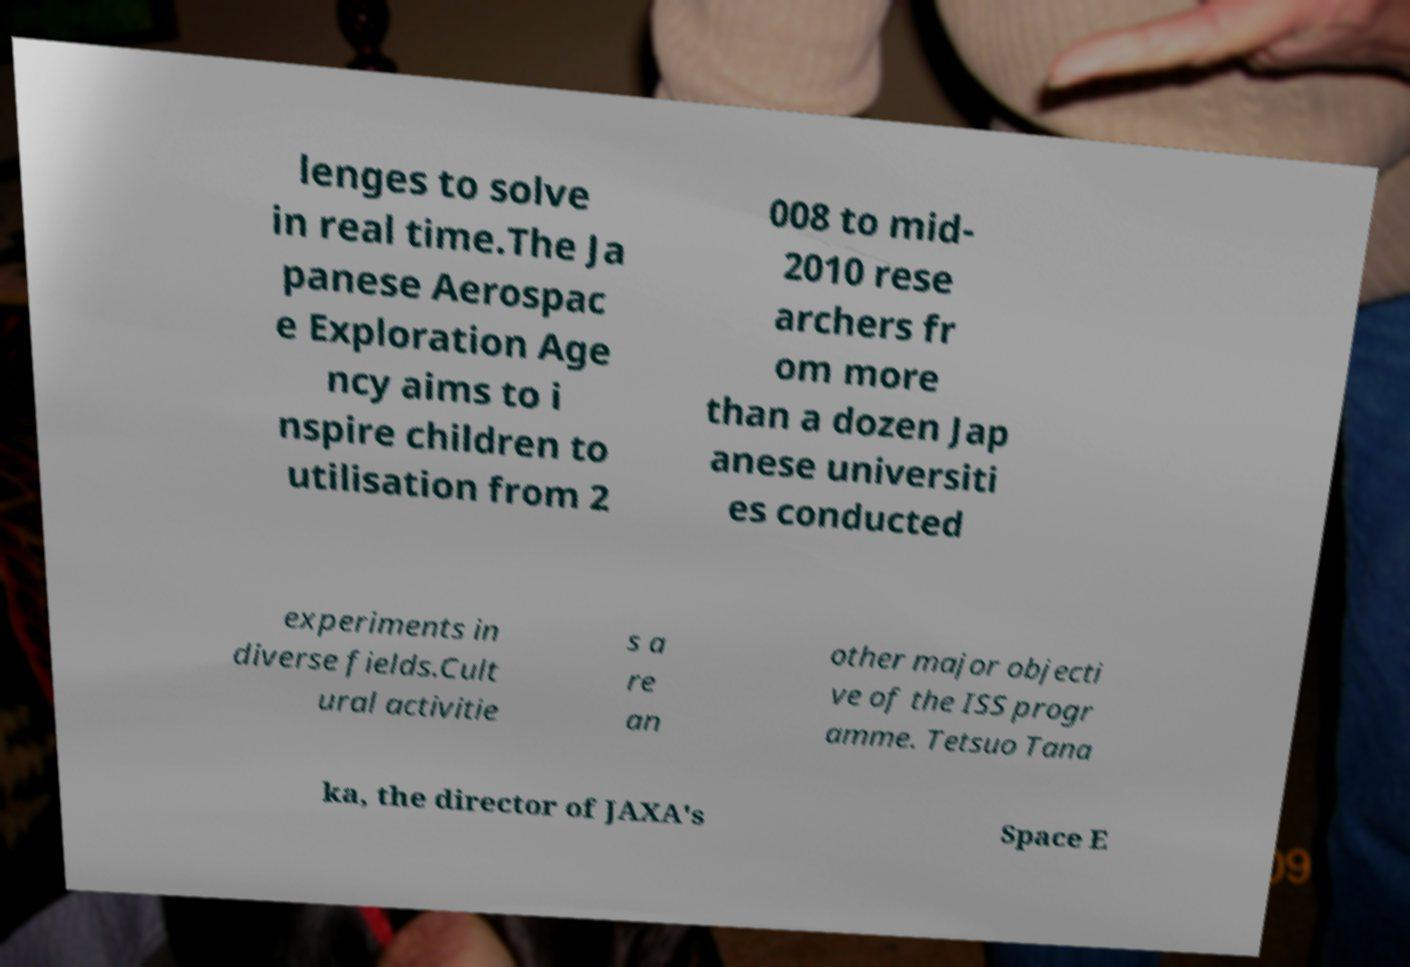I need the written content from this picture converted into text. Can you do that? lenges to solve in real time.The Ja panese Aerospac e Exploration Age ncy aims to i nspire children to utilisation from 2 008 to mid- 2010 rese archers fr om more than a dozen Jap anese universiti es conducted experiments in diverse fields.Cult ural activitie s a re an other major objecti ve of the ISS progr amme. Tetsuo Tana ka, the director of JAXA's Space E 